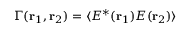Convert formula to latex. <formula><loc_0><loc_0><loc_500><loc_500>\Gamma ( { r } _ { 1 } , { r } _ { 2 } ) = \langle E ^ { \ast } ( { r } _ { 1 } ) { E } ( { r } _ { 2 } ) \rangle</formula> 